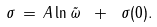<formula> <loc_0><loc_0><loc_500><loc_500>\sigma \, = \, A \ln { \tilde { \omega } } \ + \ \sigma ( 0 ) .</formula> 